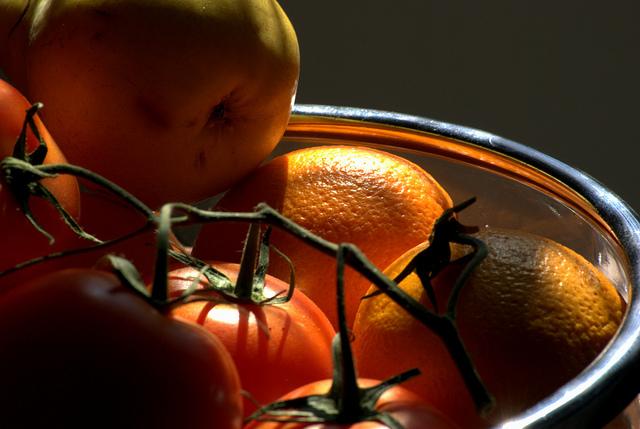What color is the bowl?
Be succinct. Silver. What fruit is on a vine?
Give a very brief answer. Tomato. Is there more than one type of food in the bowl?
Write a very short answer. Yes. 